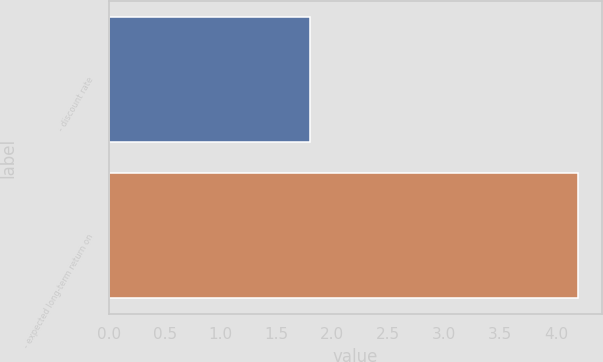Convert chart to OTSL. <chart><loc_0><loc_0><loc_500><loc_500><bar_chart><fcel>- discount rate<fcel>- expected long-term return on<nl><fcel>1.8<fcel>4.2<nl></chart> 